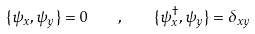Convert formula to latex. <formula><loc_0><loc_0><loc_500><loc_500>\{ \psi _ { x } , \psi _ { y } \} = 0 \quad , \quad \{ \psi ^ { \dag } _ { x } , \psi _ { y } \} = \delta _ { x y }</formula> 